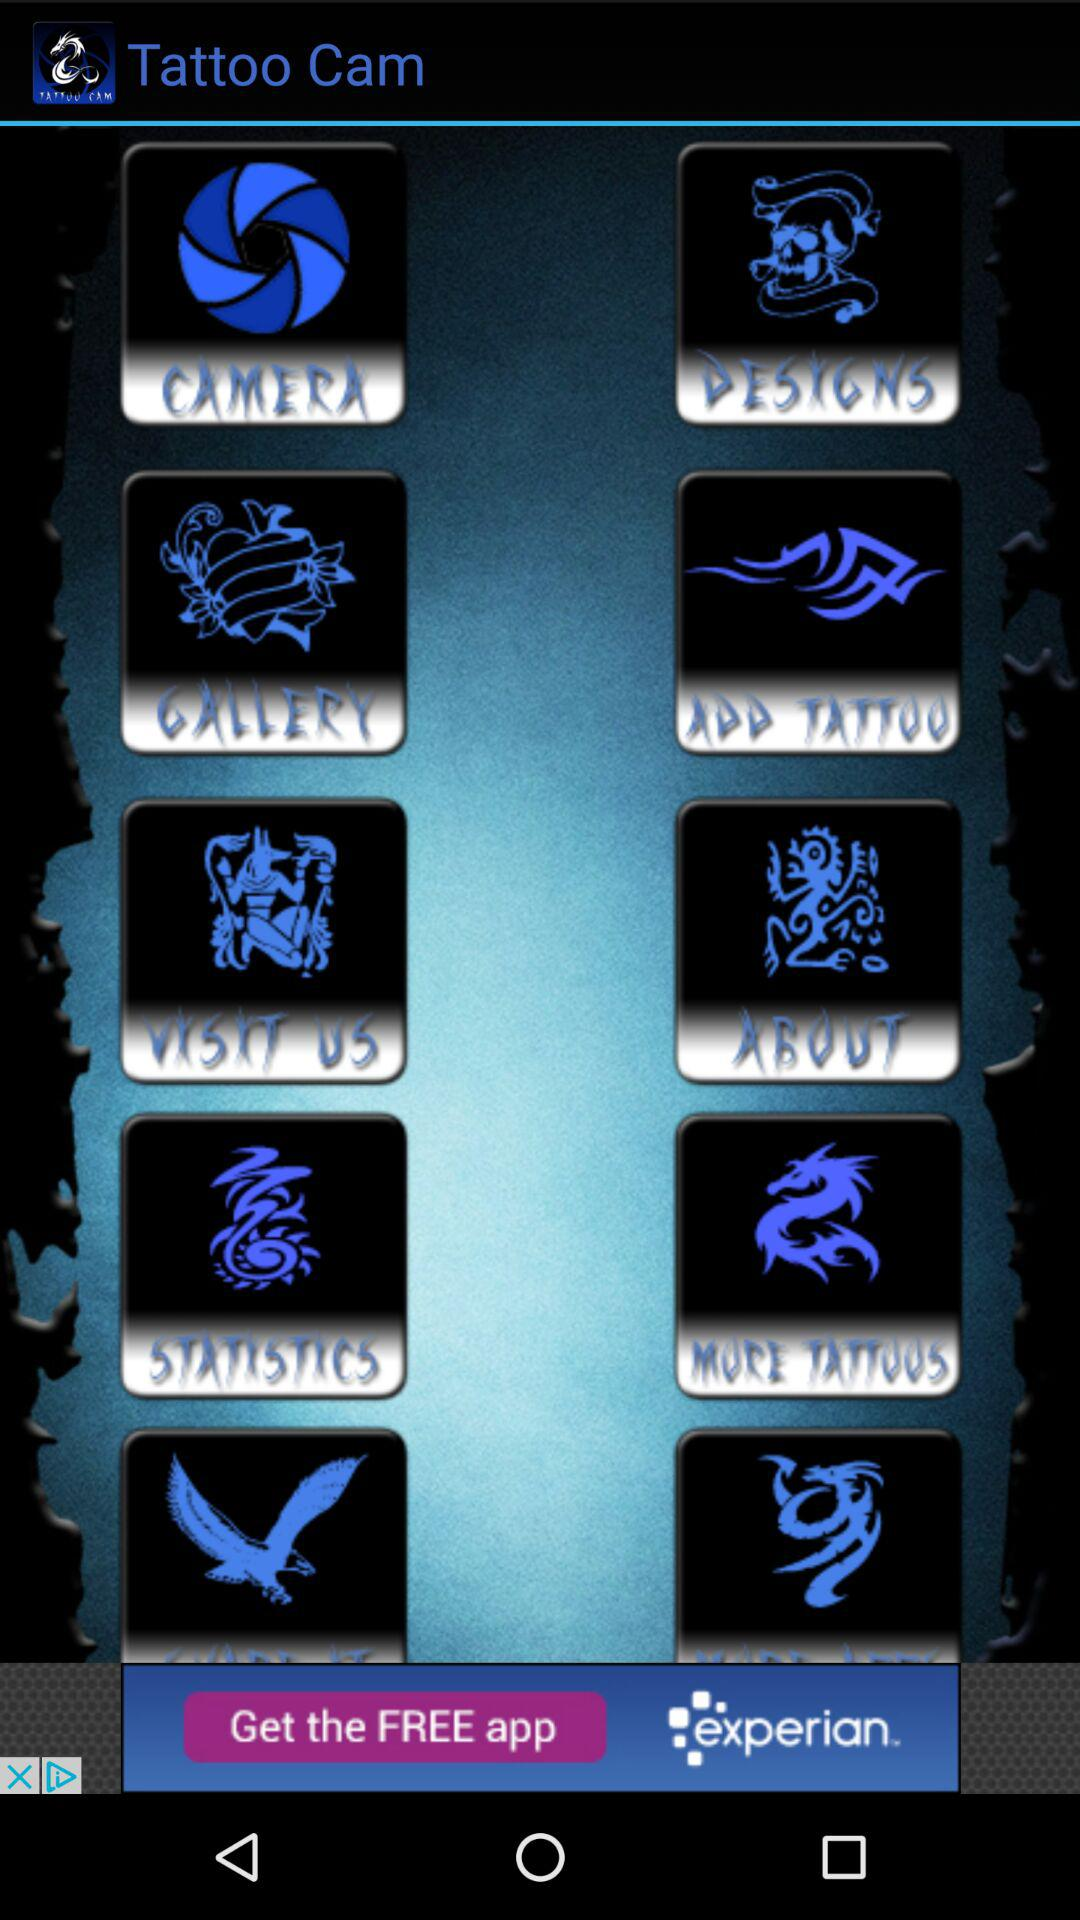What is the application name? The application name is "Tattoo Cam". 